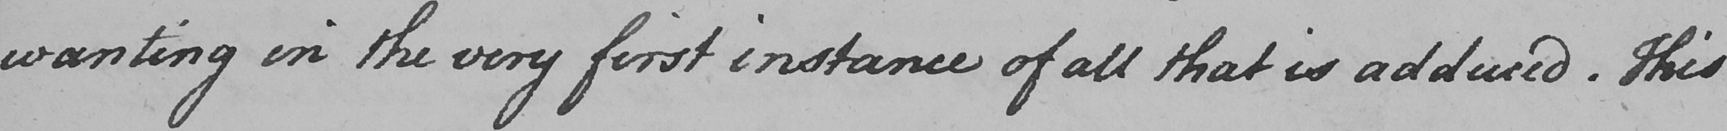What text is written in this handwritten line? wanting in the very first instance of all that is adduced . This 